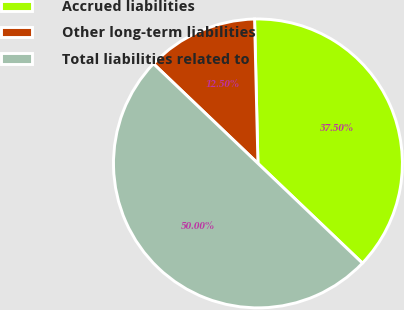Convert chart. <chart><loc_0><loc_0><loc_500><loc_500><pie_chart><fcel>Accrued liabilities<fcel>Other long-term liabilities<fcel>Total liabilities related to<nl><fcel>37.5%<fcel>12.5%<fcel>50.0%<nl></chart> 